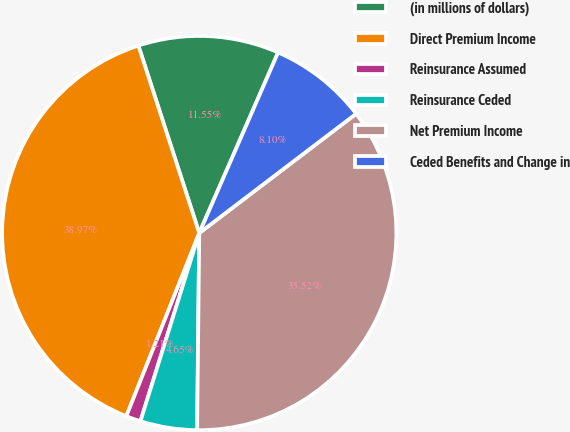Convert chart. <chart><loc_0><loc_0><loc_500><loc_500><pie_chart><fcel>(in millions of dollars)<fcel>Direct Premium Income<fcel>Reinsurance Assumed<fcel>Reinsurance Ceded<fcel>Net Premium Income<fcel>Ceded Benefits and Change in<nl><fcel>11.55%<fcel>38.97%<fcel>1.21%<fcel>4.65%<fcel>35.52%<fcel>8.1%<nl></chart> 